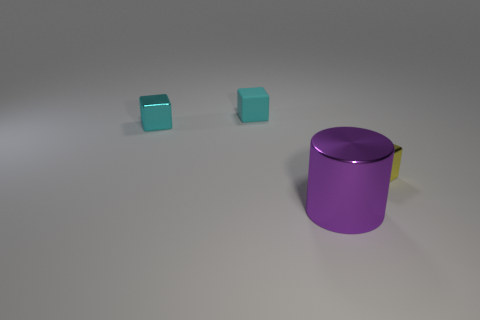Add 4 cyan metal spheres. How many objects exist? 8 Subtract all blocks. How many objects are left? 1 Subtract all purple metal cylinders. Subtract all large cyan blocks. How many objects are left? 3 Add 4 cyan metal things. How many cyan metal things are left? 5 Add 2 large yellow cylinders. How many large yellow cylinders exist? 2 Subtract 0 blue cylinders. How many objects are left? 4 